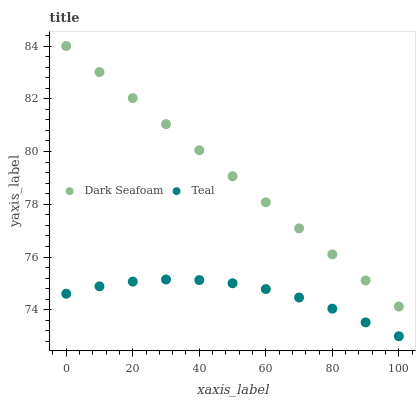Does Teal have the minimum area under the curve?
Answer yes or no. Yes. Does Dark Seafoam have the maximum area under the curve?
Answer yes or no. Yes. Does Teal have the maximum area under the curve?
Answer yes or no. No. Is Dark Seafoam the smoothest?
Answer yes or no. Yes. Is Teal the roughest?
Answer yes or no. Yes. Is Teal the smoothest?
Answer yes or no. No. Does Teal have the lowest value?
Answer yes or no. Yes. Does Dark Seafoam have the highest value?
Answer yes or no. Yes. Does Teal have the highest value?
Answer yes or no. No. Is Teal less than Dark Seafoam?
Answer yes or no. Yes. Is Dark Seafoam greater than Teal?
Answer yes or no. Yes. Does Teal intersect Dark Seafoam?
Answer yes or no. No. 